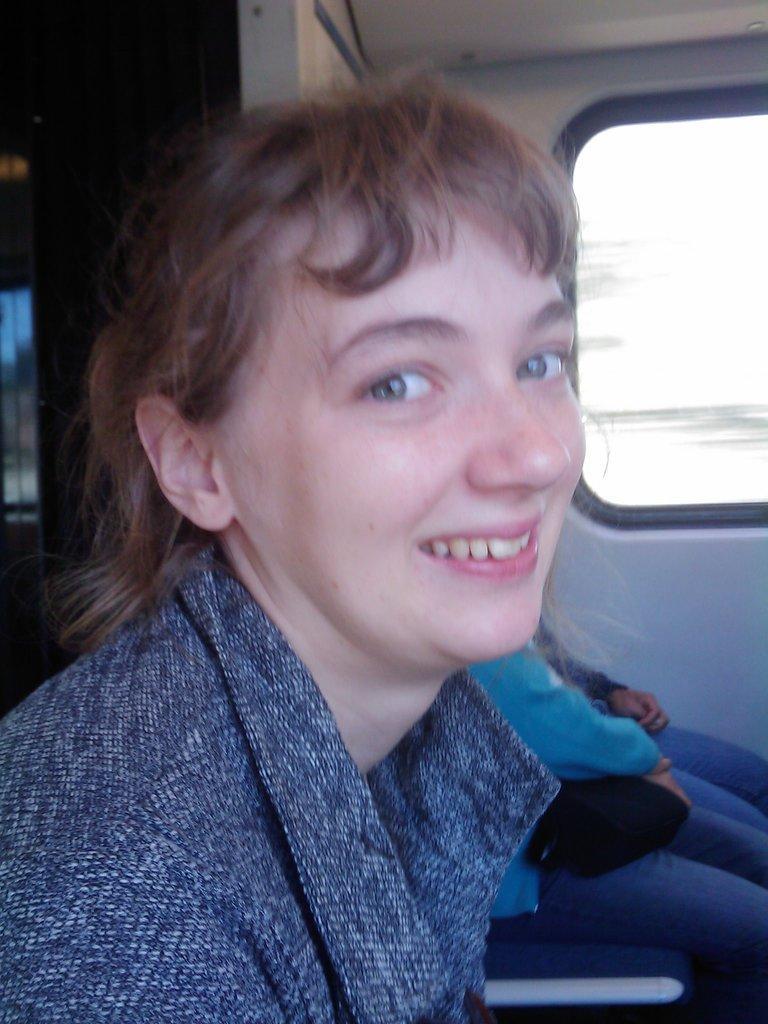Can you describe this image briefly? In this image we can see a lady. In the back two persons sitting. Also there is a wall with a window. 